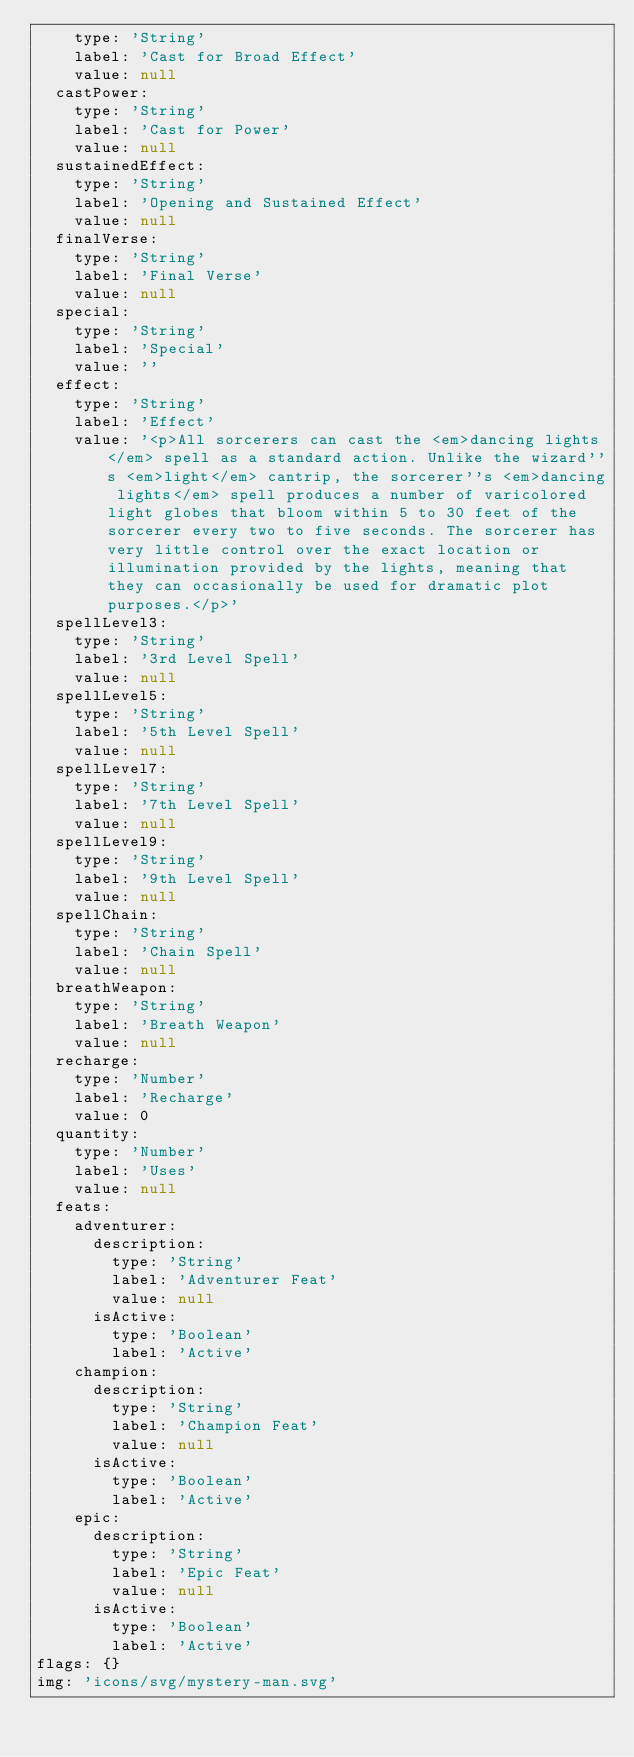Convert code to text. <code><loc_0><loc_0><loc_500><loc_500><_YAML_>    type: 'String'
    label: 'Cast for Broad Effect'
    value: null
  castPower:
    type: 'String'
    label: 'Cast for Power'
    value: null
  sustainedEffect:
    type: 'String'
    label: 'Opening and Sustained Effect'
    value: null
  finalVerse:
    type: 'String'
    label: 'Final Verse'
    value: null
  special:
    type: 'String'
    label: 'Special'
    value: ''
  effect:
    type: 'String'
    label: 'Effect'
    value: '<p>All sorcerers can cast the <em>dancing lights</em> spell as a standard action. Unlike the wizard''s <em>light</em> cantrip, the sorcerer''s <em>dancing lights</em> spell produces a number of varicolored light globes that bloom within 5 to 30 feet of the sorcerer every two to five seconds. The sorcerer has very little control over the exact location or illumination provided by the lights, meaning that they can occasionally be used for dramatic plot purposes.</p>'
  spellLevel3:
    type: 'String'
    label: '3rd Level Spell'
    value: null
  spellLevel5:
    type: 'String'
    label: '5th Level Spell'
    value: null
  spellLevel7:
    type: 'String'
    label: '7th Level Spell'
    value: null
  spellLevel9:
    type: 'String'
    label: '9th Level Spell'
    value: null
  spellChain:
    type: 'String'
    label: 'Chain Spell'
    value: null
  breathWeapon:
    type: 'String'
    label: 'Breath Weapon'
    value: null
  recharge:
    type: 'Number'
    label: 'Recharge'
    value: 0
  quantity:
    type: 'Number'
    label: 'Uses'
    value: null
  feats:
    adventurer:
      description:
        type: 'String'
        label: 'Adventurer Feat'
        value: null
      isActive:
        type: 'Boolean'
        label: 'Active'
    champion:
      description:
        type: 'String'
        label: 'Champion Feat'
        value: null
      isActive:
        type: 'Boolean'
        label: 'Active'
    epic:
      description:
        type: 'String'
        label: 'Epic Feat'
        value: null
      isActive:
        type: 'Boolean'
        label: 'Active'
flags: {}
img: 'icons/svg/mystery-man.svg'
</code> 